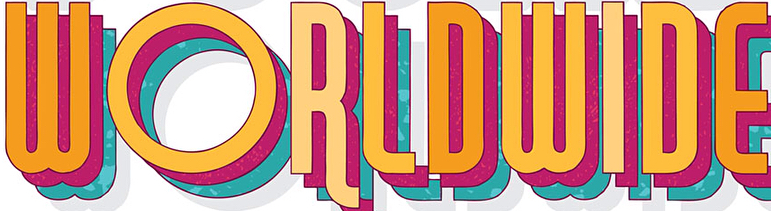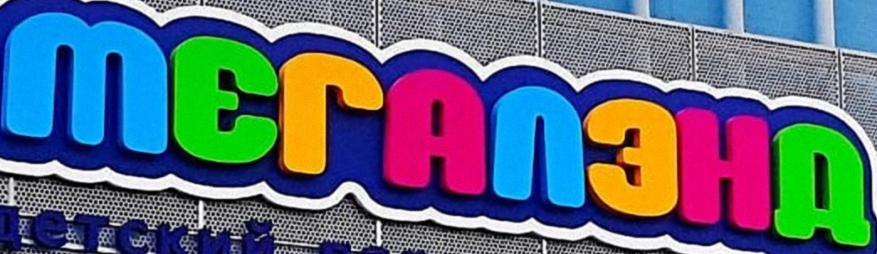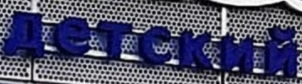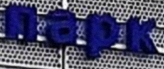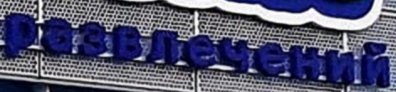Read the text content from these images in order, separated by a semicolon. WORLDWIDE; MЕГAΛЗHД; детский; пapk; paзвлeчeний 